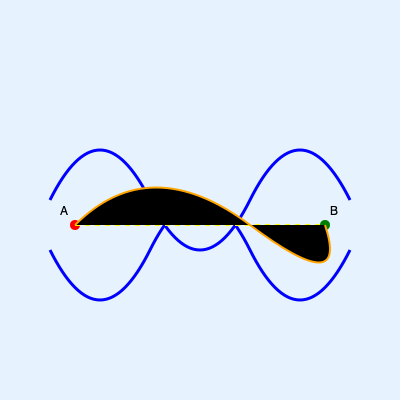Based on the sonar map of an underwater cave system, which route between points A and B is safer: the straight yellow dashed line or the curved orange line? To determine the safest route, we need to analyze the sonar map:

1. The blue lines represent the cave walls.
2. The space between the blue lines is the navigable area.
3. The yellow dashed line represents a direct route from A to B.
4. The orange curved line represents an alternative route from A to B.

Step-by-step analysis:
1. The yellow dashed line passes very close to the cave walls in multiple places, increasing the risk of collision.
2. The orange curved line maintains a more consistent distance from the cave walls throughout its path.
3. The yellow line doesn't account for the narrowing of the cave at its center, which could be dangerous.
4. The orange line follows the natural contours of the cave, reducing the risk of unexpected obstacles.
5. The curved nature of the orange line allows for easier navigation and course correction if needed.

Given the irregular shape of the cave system, following the contours of the cave (orange line) provides more room for maneuvering and reduces the risk of collision with cave walls. This makes the orange curved line the safer option for navigation between points A and B.
Answer: Curved orange line 